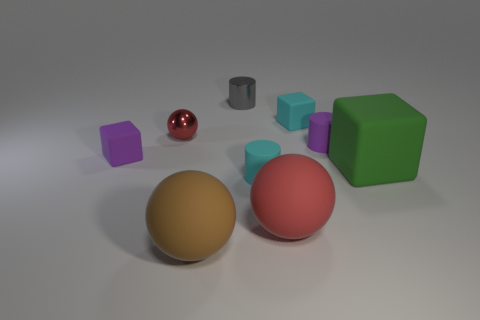What could be the potential use for this arrangement of shapes? This arrangement of shapes could be used for several purposes. It might serve as a visual study for lighting and shadow in computer graphics, a part of a cognitive test to evaluate color perception and spatial reasoning, or simply as a piece of abstract art showcasing geometric forms. In design contexts, it could also be a reference for understanding how different shapes and colors interact within a space. 